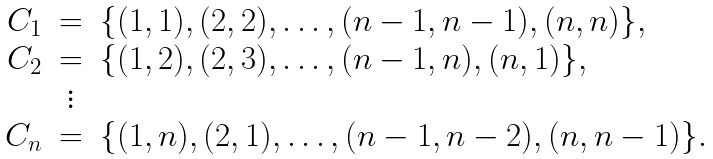Convert formula to latex. <formula><loc_0><loc_0><loc_500><loc_500>\begin{array} { r c l } C _ { 1 } & = & \{ ( 1 , 1 ) , ( 2 , 2 ) , \dots , ( n - 1 , n - 1 ) , ( n , n ) \} , \\ C _ { 2 } & = & \{ ( 1 , 2 ) , ( 2 , 3 ) , \dots , ( n - 1 , n ) , ( n , 1 ) \} , \\ & \vdots & \\ C _ { n } & = & \{ ( 1 , n ) , ( 2 , 1 ) , \dots , ( n - 1 , n - 2 ) , ( n , n - 1 ) \} . \\ \end{array}</formula> 